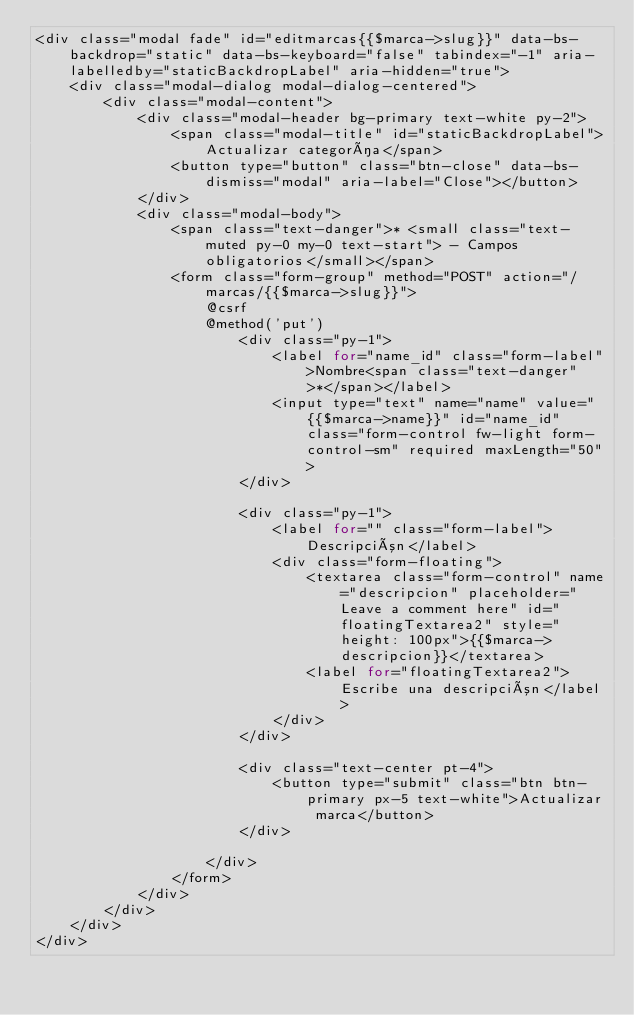Convert code to text. <code><loc_0><loc_0><loc_500><loc_500><_PHP_><div class="modal fade" id="editmarcas{{$marca->slug}}" data-bs-backdrop="static" data-bs-keyboard="false" tabindex="-1" aria-labelledby="staticBackdropLabel" aria-hidden="true">
    <div class="modal-dialog modal-dialog-centered">
        <div class="modal-content">
            <div class="modal-header bg-primary text-white py-2">
                <span class="modal-title" id="staticBackdropLabel">Actualizar categoría</span>
                <button type="button" class="btn-close" data-bs-dismiss="modal" aria-label="Close"></button>
            </div>
            <div class="modal-body">
                <span class="text-danger">* <small class="text-muted py-0 my-0 text-start"> - Campos obligatorios</small></span>
                <form class="form-group" method="POST" action="/marcas/{{$marca->slug}}">      
                    @csrf
                    @method('put')
                        <div class="py-1">
                            <label for="name_id" class="form-label">Nombre<span class="text-danger">*</span></label>
                            <input type="text" name="name" value="{{$marca->name}}" id="name_id" class="form-control fw-light form-control-sm" required maxLength="50">
                        </div>

                        <div class="py-1">
                            <label for="" class="form-label">Descripción</label>
                            <div class="form-floating">
                                <textarea class="form-control" name="descripcion" placeholder="Leave a comment here" id="floatingTextarea2" style="height: 100px">{{$marca->descripcion}}</textarea>
                                <label for="floatingTextarea2">Escribe una descripción</label>
                            </div>
                        </div>
                        
                        <div class="text-center pt-4">
                            <button type="submit" class="btn btn-primary px-5 text-white">Actualizar marca</button>   
                        </div>
                        
                    </div>
                </form>
            </div>
        </div>
    </div>
</div></code> 